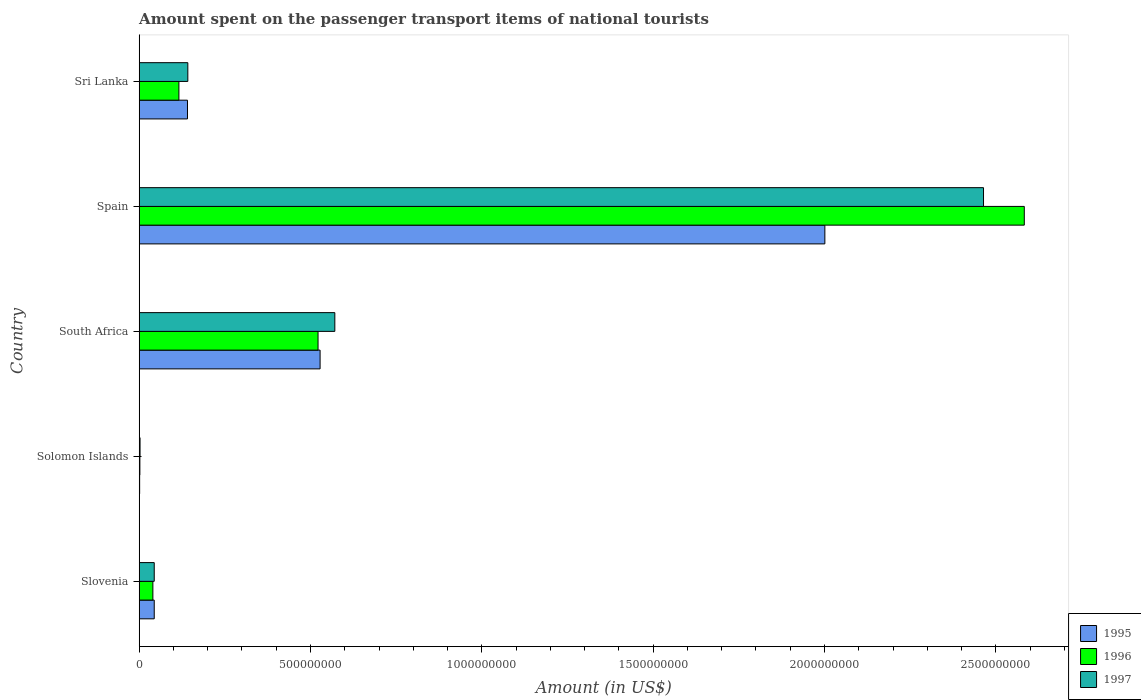How many groups of bars are there?
Give a very brief answer. 5. Are the number of bars per tick equal to the number of legend labels?
Provide a short and direct response. Yes. How many bars are there on the 5th tick from the top?
Give a very brief answer. 3. What is the label of the 4th group of bars from the top?
Give a very brief answer. Solomon Islands. What is the amount spent on the passenger transport items of national tourists in 1996 in Spain?
Your answer should be compact. 2.58e+09. Across all countries, what is the maximum amount spent on the passenger transport items of national tourists in 1995?
Keep it short and to the point. 2.00e+09. Across all countries, what is the minimum amount spent on the passenger transport items of national tourists in 1997?
Offer a terse response. 2.60e+06. In which country was the amount spent on the passenger transport items of national tourists in 1997 minimum?
Ensure brevity in your answer.  Solomon Islands. What is the total amount spent on the passenger transport items of national tourists in 1997 in the graph?
Give a very brief answer. 3.22e+09. What is the difference between the amount spent on the passenger transport items of national tourists in 1995 in Spain and that in Sri Lanka?
Ensure brevity in your answer.  1.86e+09. What is the difference between the amount spent on the passenger transport items of national tourists in 1995 in Spain and the amount spent on the passenger transport items of national tourists in 1997 in South Africa?
Offer a terse response. 1.43e+09. What is the average amount spent on the passenger transport items of national tourists in 1996 per country?
Offer a terse response. 6.53e+08. What is the difference between the amount spent on the passenger transport items of national tourists in 1997 and amount spent on the passenger transport items of national tourists in 1995 in Slovenia?
Your answer should be very brief. 0. What is the ratio of the amount spent on the passenger transport items of national tourists in 1996 in South Africa to that in Spain?
Ensure brevity in your answer.  0.2. Is the amount spent on the passenger transport items of national tourists in 1996 in South Africa less than that in Sri Lanka?
Make the answer very short. No. What is the difference between the highest and the second highest amount spent on the passenger transport items of national tourists in 1996?
Keep it short and to the point. 2.06e+09. What is the difference between the highest and the lowest amount spent on the passenger transport items of national tourists in 1997?
Provide a succinct answer. 2.46e+09. In how many countries, is the amount spent on the passenger transport items of national tourists in 1997 greater than the average amount spent on the passenger transport items of national tourists in 1997 taken over all countries?
Provide a short and direct response. 1. Is the sum of the amount spent on the passenger transport items of national tourists in 1995 in Solomon Islands and Spain greater than the maximum amount spent on the passenger transport items of national tourists in 1996 across all countries?
Your answer should be very brief. No. Is it the case that in every country, the sum of the amount spent on the passenger transport items of national tourists in 1995 and amount spent on the passenger transport items of national tourists in 1996 is greater than the amount spent on the passenger transport items of national tourists in 1997?
Provide a succinct answer. Yes. How many countries are there in the graph?
Your answer should be very brief. 5. What is the difference between two consecutive major ticks on the X-axis?
Give a very brief answer. 5.00e+08. Does the graph contain grids?
Make the answer very short. No. Where does the legend appear in the graph?
Your answer should be very brief. Bottom right. How many legend labels are there?
Your answer should be very brief. 3. How are the legend labels stacked?
Make the answer very short. Vertical. What is the title of the graph?
Ensure brevity in your answer.  Amount spent on the passenger transport items of national tourists. What is the label or title of the Y-axis?
Ensure brevity in your answer.  Country. What is the Amount (in US$) in 1995 in Slovenia?
Keep it short and to the point. 4.40e+07. What is the Amount (in US$) in 1996 in Slovenia?
Give a very brief answer. 4.00e+07. What is the Amount (in US$) in 1997 in Slovenia?
Your answer should be very brief. 4.40e+07. What is the Amount (in US$) in 1995 in Solomon Islands?
Your answer should be compact. 1.40e+06. What is the Amount (in US$) of 1996 in Solomon Islands?
Offer a terse response. 2.10e+06. What is the Amount (in US$) of 1997 in Solomon Islands?
Your response must be concise. 2.60e+06. What is the Amount (in US$) of 1995 in South Africa?
Your response must be concise. 5.28e+08. What is the Amount (in US$) in 1996 in South Africa?
Your response must be concise. 5.22e+08. What is the Amount (in US$) in 1997 in South Africa?
Your answer should be compact. 5.71e+08. What is the Amount (in US$) of 1995 in Spain?
Provide a succinct answer. 2.00e+09. What is the Amount (in US$) of 1996 in Spain?
Your response must be concise. 2.58e+09. What is the Amount (in US$) of 1997 in Spain?
Give a very brief answer. 2.46e+09. What is the Amount (in US$) of 1995 in Sri Lanka?
Ensure brevity in your answer.  1.41e+08. What is the Amount (in US$) in 1996 in Sri Lanka?
Your answer should be very brief. 1.16e+08. What is the Amount (in US$) of 1997 in Sri Lanka?
Your answer should be very brief. 1.42e+08. Across all countries, what is the maximum Amount (in US$) in 1995?
Offer a terse response. 2.00e+09. Across all countries, what is the maximum Amount (in US$) in 1996?
Your answer should be very brief. 2.58e+09. Across all countries, what is the maximum Amount (in US$) in 1997?
Your answer should be compact. 2.46e+09. Across all countries, what is the minimum Amount (in US$) in 1995?
Provide a short and direct response. 1.40e+06. Across all countries, what is the minimum Amount (in US$) of 1996?
Provide a short and direct response. 2.10e+06. Across all countries, what is the minimum Amount (in US$) in 1997?
Provide a succinct answer. 2.60e+06. What is the total Amount (in US$) in 1995 in the graph?
Provide a succinct answer. 2.72e+09. What is the total Amount (in US$) in 1996 in the graph?
Make the answer very short. 3.26e+09. What is the total Amount (in US$) of 1997 in the graph?
Ensure brevity in your answer.  3.22e+09. What is the difference between the Amount (in US$) in 1995 in Slovenia and that in Solomon Islands?
Make the answer very short. 4.26e+07. What is the difference between the Amount (in US$) of 1996 in Slovenia and that in Solomon Islands?
Provide a short and direct response. 3.79e+07. What is the difference between the Amount (in US$) of 1997 in Slovenia and that in Solomon Islands?
Your answer should be very brief. 4.14e+07. What is the difference between the Amount (in US$) in 1995 in Slovenia and that in South Africa?
Make the answer very short. -4.84e+08. What is the difference between the Amount (in US$) of 1996 in Slovenia and that in South Africa?
Give a very brief answer. -4.82e+08. What is the difference between the Amount (in US$) of 1997 in Slovenia and that in South Africa?
Offer a terse response. -5.27e+08. What is the difference between the Amount (in US$) of 1995 in Slovenia and that in Spain?
Your answer should be very brief. -1.96e+09. What is the difference between the Amount (in US$) in 1996 in Slovenia and that in Spain?
Provide a short and direct response. -2.54e+09. What is the difference between the Amount (in US$) of 1997 in Slovenia and that in Spain?
Make the answer very short. -2.42e+09. What is the difference between the Amount (in US$) in 1995 in Slovenia and that in Sri Lanka?
Your response must be concise. -9.70e+07. What is the difference between the Amount (in US$) in 1996 in Slovenia and that in Sri Lanka?
Your answer should be compact. -7.60e+07. What is the difference between the Amount (in US$) in 1997 in Slovenia and that in Sri Lanka?
Ensure brevity in your answer.  -9.80e+07. What is the difference between the Amount (in US$) in 1995 in Solomon Islands and that in South Africa?
Keep it short and to the point. -5.27e+08. What is the difference between the Amount (in US$) of 1996 in Solomon Islands and that in South Africa?
Offer a very short reply. -5.20e+08. What is the difference between the Amount (in US$) in 1997 in Solomon Islands and that in South Africa?
Make the answer very short. -5.68e+08. What is the difference between the Amount (in US$) in 1995 in Solomon Islands and that in Spain?
Offer a very short reply. -2.00e+09. What is the difference between the Amount (in US$) in 1996 in Solomon Islands and that in Spain?
Keep it short and to the point. -2.58e+09. What is the difference between the Amount (in US$) of 1997 in Solomon Islands and that in Spain?
Provide a short and direct response. -2.46e+09. What is the difference between the Amount (in US$) of 1995 in Solomon Islands and that in Sri Lanka?
Your answer should be very brief. -1.40e+08. What is the difference between the Amount (in US$) in 1996 in Solomon Islands and that in Sri Lanka?
Your answer should be compact. -1.14e+08. What is the difference between the Amount (in US$) of 1997 in Solomon Islands and that in Sri Lanka?
Your response must be concise. -1.39e+08. What is the difference between the Amount (in US$) of 1995 in South Africa and that in Spain?
Give a very brief answer. -1.47e+09. What is the difference between the Amount (in US$) of 1996 in South Africa and that in Spain?
Ensure brevity in your answer.  -2.06e+09. What is the difference between the Amount (in US$) in 1997 in South Africa and that in Spain?
Provide a short and direct response. -1.89e+09. What is the difference between the Amount (in US$) in 1995 in South Africa and that in Sri Lanka?
Your answer should be compact. 3.87e+08. What is the difference between the Amount (in US$) in 1996 in South Africa and that in Sri Lanka?
Make the answer very short. 4.06e+08. What is the difference between the Amount (in US$) of 1997 in South Africa and that in Sri Lanka?
Make the answer very short. 4.29e+08. What is the difference between the Amount (in US$) of 1995 in Spain and that in Sri Lanka?
Your answer should be compact. 1.86e+09. What is the difference between the Amount (in US$) of 1996 in Spain and that in Sri Lanka?
Offer a terse response. 2.47e+09. What is the difference between the Amount (in US$) of 1997 in Spain and that in Sri Lanka?
Give a very brief answer. 2.32e+09. What is the difference between the Amount (in US$) in 1995 in Slovenia and the Amount (in US$) in 1996 in Solomon Islands?
Ensure brevity in your answer.  4.19e+07. What is the difference between the Amount (in US$) in 1995 in Slovenia and the Amount (in US$) in 1997 in Solomon Islands?
Keep it short and to the point. 4.14e+07. What is the difference between the Amount (in US$) of 1996 in Slovenia and the Amount (in US$) of 1997 in Solomon Islands?
Keep it short and to the point. 3.74e+07. What is the difference between the Amount (in US$) of 1995 in Slovenia and the Amount (in US$) of 1996 in South Africa?
Give a very brief answer. -4.78e+08. What is the difference between the Amount (in US$) of 1995 in Slovenia and the Amount (in US$) of 1997 in South Africa?
Your response must be concise. -5.27e+08. What is the difference between the Amount (in US$) of 1996 in Slovenia and the Amount (in US$) of 1997 in South Africa?
Keep it short and to the point. -5.31e+08. What is the difference between the Amount (in US$) of 1995 in Slovenia and the Amount (in US$) of 1996 in Spain?
Offer a terse response. -2.54e+09. What is the difference between the Amount (in US$) in 1995 in Slovenia and the Amount (in US$) in 1997 in Spain?
Provide a short and direct response. -2.42e+09. What is the difference between the Amount (in US$) of 1996 in Slovenia and the Amount (in US$) of 1997 in Spain?
Your answer should be very brief. -2.42e+09. What is the difference between the Amount (in US$) of 1995 in Slovenia and the Amount (in US$) of 1996 in Sri Lanka?
Your answer should be very brief. -7.20e+07. What is the difference between the Amount (in US$) in 1995 in Slovenia and the Amount (in US$) in 1997 in Sri Lanka?
Keep it short and to the point. -9.80e+07. What is the difference between the Amount (in US$) in 1996 in Slovenia and the Amount (in US$) in 1997 in Sri Lanka?
Keep it short and to the point. -1.02e+08. What is the difference between the Amount (in US$) in 1995 in Solomon Islands and the Amount (in US$) in 1996 in South Africa?
Give a very brief answer. -5.21e+08. What is the difference between the Amount (in US$) in 1995 in Solomon Islands and the Amount (in US$) in 1997 in South Africa?
Your answer should be very brief. -5.70e+08. What is the difference between the Amount (in US$) of 1996 in Solomon Islands and the Amount (in US$) of 1997 in South Africa?
Provide a short and direct response. -5.69e+08. What is the difference between the Amount (in US$) in 1995 in Solomon Islands and the Amount (in US$) in 1996 in Spain?
Give a very brief answer. -2.58e+09. What is the difference between the Amount (in US$) in 1995 in Solomon Islands and the Amount (in US$) in 1997 in Spain?
Keep it short and to the point. -2.46e+09. What is the difference between the Amount (in US$) of 1996 in Solomon Islands and the Amount (in US$) of 1997 in Spain?
Provide a short and direct response. -2.46e+09. What is the difference between the Amount (in US$) of 1995 in Solomon Islands and the Amount (in US$) of 1996 in Sri Lanka?
Your answer should be compact. -1.15e+08. What is the difference between the Amount (in US$) of 1995 in Solomon Islands and the Amount (in US$) of 1997 in Sri Lanka?
Keep it short and to the point. -1.41e+08. What is the difference between the Amount (in US$) in 1996 in Solomon Islands and the Amount (in US$) in 1997 in Sri Lanka?
Keep it short and to the point. -1.40e+08. What is the difference between the Amount (in US$) of 1995 in South Africa and the Amount (in US$) of 1996 in Spain?
Give a very brief answer. -2.06e+09. What is the difference between the Amount (in US$) of 1995 in South Africa and the Amount (in US$) of 1997 in Spain?
Your answer should be very brief. -1.94e+09. What is the difference between the Amount (in US$) of 1996 in South Africa and the Amount (in US$) of 1997 in Spain?
Provide a short and direct response. -1.94e+09. What is the difference between the Amount (in US$) of 1995 in South Africa and the Amount (in US$) of 1996 in Sri Lanka?
Offer a very short reply. 4.12e+08. What is the difference between the Amount (in US$) in 1995 in South Africa and the Amount (in US$) in 1997 in Sri Lanka?
Ensure brevity in your answer.  3.86e+08. What is the difference between the Amount (in US$) in 1996 in South Africa and the Amount (in US$) in 1997 in Sri Lanka?
Keep it short and to the point. 3.80e+08. What is the difference between the Amount (in US$) of 1995 in Spain and the Amount (in US$) of 1996 in Sri Lanka?
Ensure brevity in your answer.  1.88e+09. What is the difference between the Amount (in US$) of 1995 in Spain and the Amount (in US$) of 1997 in Sri Lanka?
Your answer should be compact. 1.86e+09. What is the difference between the Amount (in US$) in 1996 in Spain and the Amount (in US$) in 1997 in Sri Lanka?
Offer a very short reply. 2.44e+09. What is the average Amount (in US$) in 1995 per country?
Your response must be concise. 5.43e+08. What is the average Amount (in US$) in 1996 per country?
Ensure brevity in your answer.  6.53e+08. What is the average Amount (in US$) of 1997 per country?
Ensure brevity in your answer.  6.45e+08. What is the difference between the Amount (in US$) in 1995 and Amount (in US$) in 1997 in Slovenia?
Make the answer very short. 0. What is the difference between the Amount (in US$) in 1996 and Amount (in US$) in 1997 in Slovenia?
Ensure brevity in your answer.  -4.00e+06. What is the difference between the Amount (in US$) of 1995 and Amount (in US$) of 1996 in Solomon Islands?
Keep it short and to the point. -7.00e+05. What is the difference between the Amount (in US$) of 1995 and Amount (in US$) of 1997 in Solomon Islands?
Give a very brief answer. -1.20e+06. What is the difference between the Amount (in US$) in 1996 and Amount (in US$) in 1997 in Solomon Islands?
Keep it short and to the point. -5.00e+05. What is the difference between the Amount (in US$) of 1995 and Amount (in US$) of 1997 in South Africa?
Give a very brief answer. -4.30e+07. What is the difference between the Amount (in US$) in 1996 and Amount (in US$) in 1997 in South Africa?
Offer a terse response. -4.90e+07. What is the difference between the Amount (in US$) of 1995 and Amount (in US$) of 1996 in Spain?
Provide a short and direct response. -5.82e+08. What is the difference between the Amount (in US$) of 1995 and Amount (in US$) of 1997 in Spain?
Ensure brevity in your answer.  -4.63e+08. What is the difference between the Amount (in US$) in 1996 and Amount (in US$) in 1997 in Spain?
Make the answer very short. 1.19e+08. What is the difference between the Amount (in US$) of 1995 and Amount (in US$) of 1996 in Sri Lanka?
Keep it short and to the point. 2.50e+07. What is the difference between the Amount (in US$) in 1995 and Amount (in US$) in 1997 in Sri Lanka?
Your answer should be compact. -1.00e+06. What is the difference between the Amount (in US$) of 1996 and Amount (in US$) of 1997 in Sri Lanka?
Your answer should be compact. -2.60e+07. What is the ratio of the Amount (in US$) of 1995 in Slovenia to that in Solomon Islands?
Offer a terse response. 31.43. What is the ratio of the Amount (in US$) of 1996 in Slovenia to that in Solomon Islands?
Give a very brief answer. 19.05. What is the ratio of the Amount (in US$) of 1997 in Slovenia to that in Solomon Islands?
Provide a short and direct response. 16.92. What is the ratio of the Amount (in US$) of 1995 in Slovenia to that in South Africa?
Your answer should be very brief. 0.08. What is the ratio of the Amount (in US$) of 1996 in Slovenia to that in South Africa?
Your answer should be compact. 0.08. What is the ratio of the Amount (in US$) of 1997 in Slovenia to that in South Africa?
Your answer should be very brief. 0.08. What is the ratio of the Amount (in US$) of 1995 in Slovenia to that in Spain?
Your answer should be compact. 0.02. What is the ratio of the Amount (in US$) of 1996 in Slovenia to that in Spain?
Your answer should be very brief. 0.02. What is the ratio of the Amount (in US$) in 1997 in Slovenia to that in Spain?
Provide a short and direct response. 0.02. What is the ratio of the Amount (in US$) in 1995 in Slovenia to that in Sri Lanka?
Keep it short and to the point. 0.31. What is the ratio of the Amount (in US$) in 1996 in Slovenia to that in Sri Lanka?
Offer a very short reply. 0.34. What is the ratio of the Amount (in US$) in 1997 in Slovenia to that in Sri Lanka?
Offer a very short reply. 0.31. What is the ratio of the Amount (in US$) of 1995 in Solomon Islands to that in South Africa?
Provide a succinct answer. 0. What is the ratio of the Amount (in US$) in 1996 in Solomon Islands to that in South Africa?
Ensure brevity in your answer.  0. What is the ratio of the Amount (in US$) of 1997 in Solomon Islands to that in South Africa?
Give a very brief answer. 0. What is the ratio of the Amount (in US$) of 1995 in Solomon Islands to that in Spain?
Keep it short and to the point. 0. What is the ratio of the Amount (in US$) in 1996 in Solomon Islands to that in Spain?
Your answer should be compact. 0. What is the ratio of the Amount (in US$) in 1997 in Solomon Islands to that in Spain?
Offer a very short reply. 0. What is the ratio of the Amount (in US$) in 1995 in Solomon Islands to that in Sri Lanka?
Your response must be concise. 0.01. What is the ratio of the Amount (in US$) of 1996 in Solomon Islands to that in Sri Lanka?
Give a very brief answer. 0.02. What is the ratio of the Amount (in US$) in 1997 in Solomon Islands to that in Sri Lanka?
Your answer should be very brief. 0.02. What is the ratio of the Amount (in US$) of 1995 in South Africa to that in Spain?
Your answer should be compact. 0.26. What is the ratio of the Amount (in US$) in 1996 in South Africa to that in Spain?
Your response must be concise. 0.2. What is the ratio of the Amount (in US$) in 1997 in South Africa to that in Spain?
Provide a succinct answer. 0.23. What is the ratio of the Amount (in US$) of 1995 in South Africa to that in Sri Lanka?
Your answer should be very brief. 3.74. What is the ratio of the Amount (in US$) in 1997 in South Africa to that in Sri Lanka?
Offer a very short reply. 4.02. What is the ratio of the Amount (in US$) of 1995 in Spain to that in Sri Lanka?
Provide a succinct answer. 14.19. What is the ratio of the Amount (in US$) of 1996 in Spain to that in Sri Lanka?
Provide a short and direct response. 22.27. What is the ratio of the Amount (in US$) in 1997 in Spain to that in Sri Lanka?
Offer a very short reply. 17.35. What is the difference between the highest and the second highest Amount (in US$) in 1995?
Provide a short and direct response. 1.47e+09. What is the difference between the highest and the second highest Amount (in US$) of 1996?
Keep it short and to the point. 2.06e+09. What is the difference between the highest and the second highest Amount (in US$) in 1997?
Your response must be concise. 1.89e+09. What is the difference between the highest and the lowest Amount (in US$) of 1995?
Your answer should be very brief. 2.00e+09. What is the difference between the highest and the lowest Amount (in US$) in 1996?
Offer a terse response. 2.58e+09. What is the difference between the highest and the lowest Amount (in US$) of 1997?
Offer a terse response. 2.46e+09. 